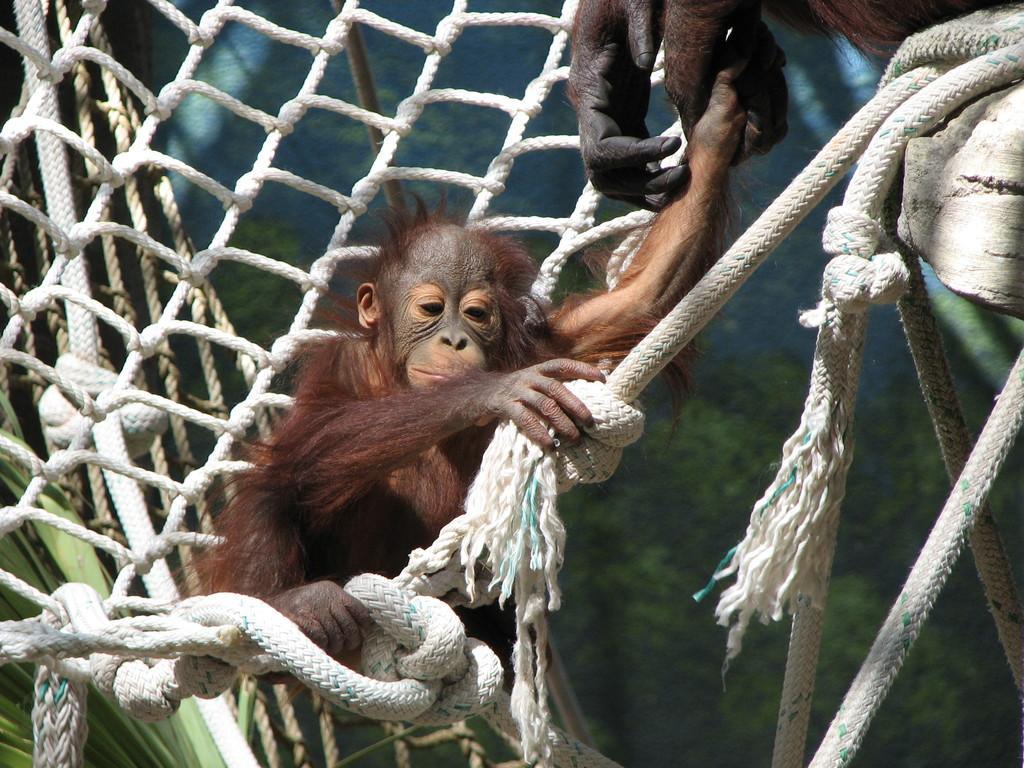In one or two sentences, can you explain what this image depicts? In this image there is a monkey sitting on the rope. 